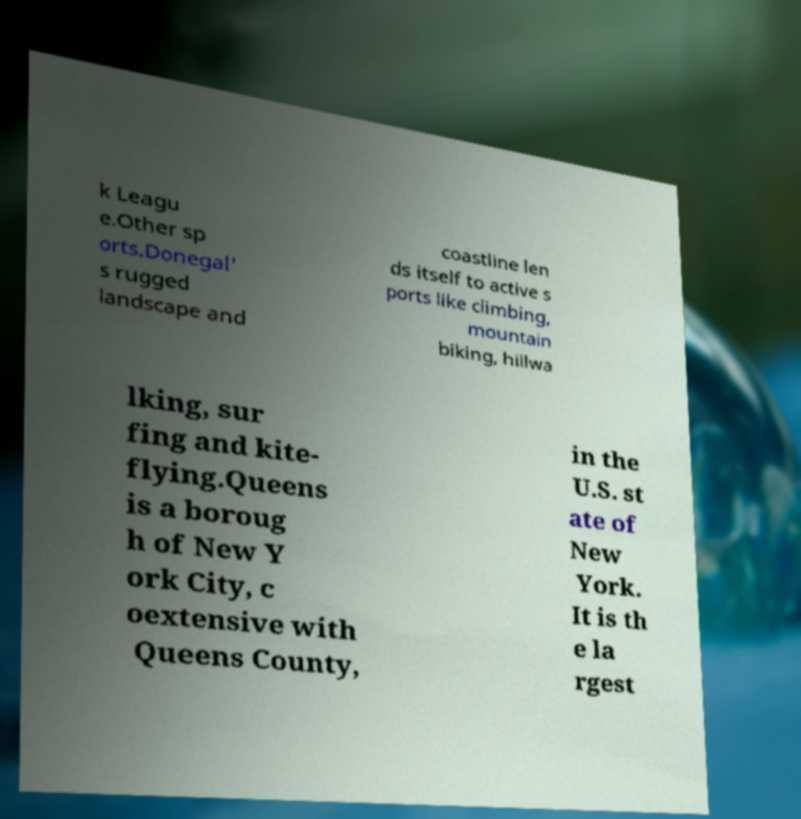What makes Queens, New York significant? Queens is significant for being the largest borough of New York City in terms of area. It is diverse, hosting numerous ethnic communities, and is known for its rich cultural life, encompassing various restaurants, museums, and parks. 